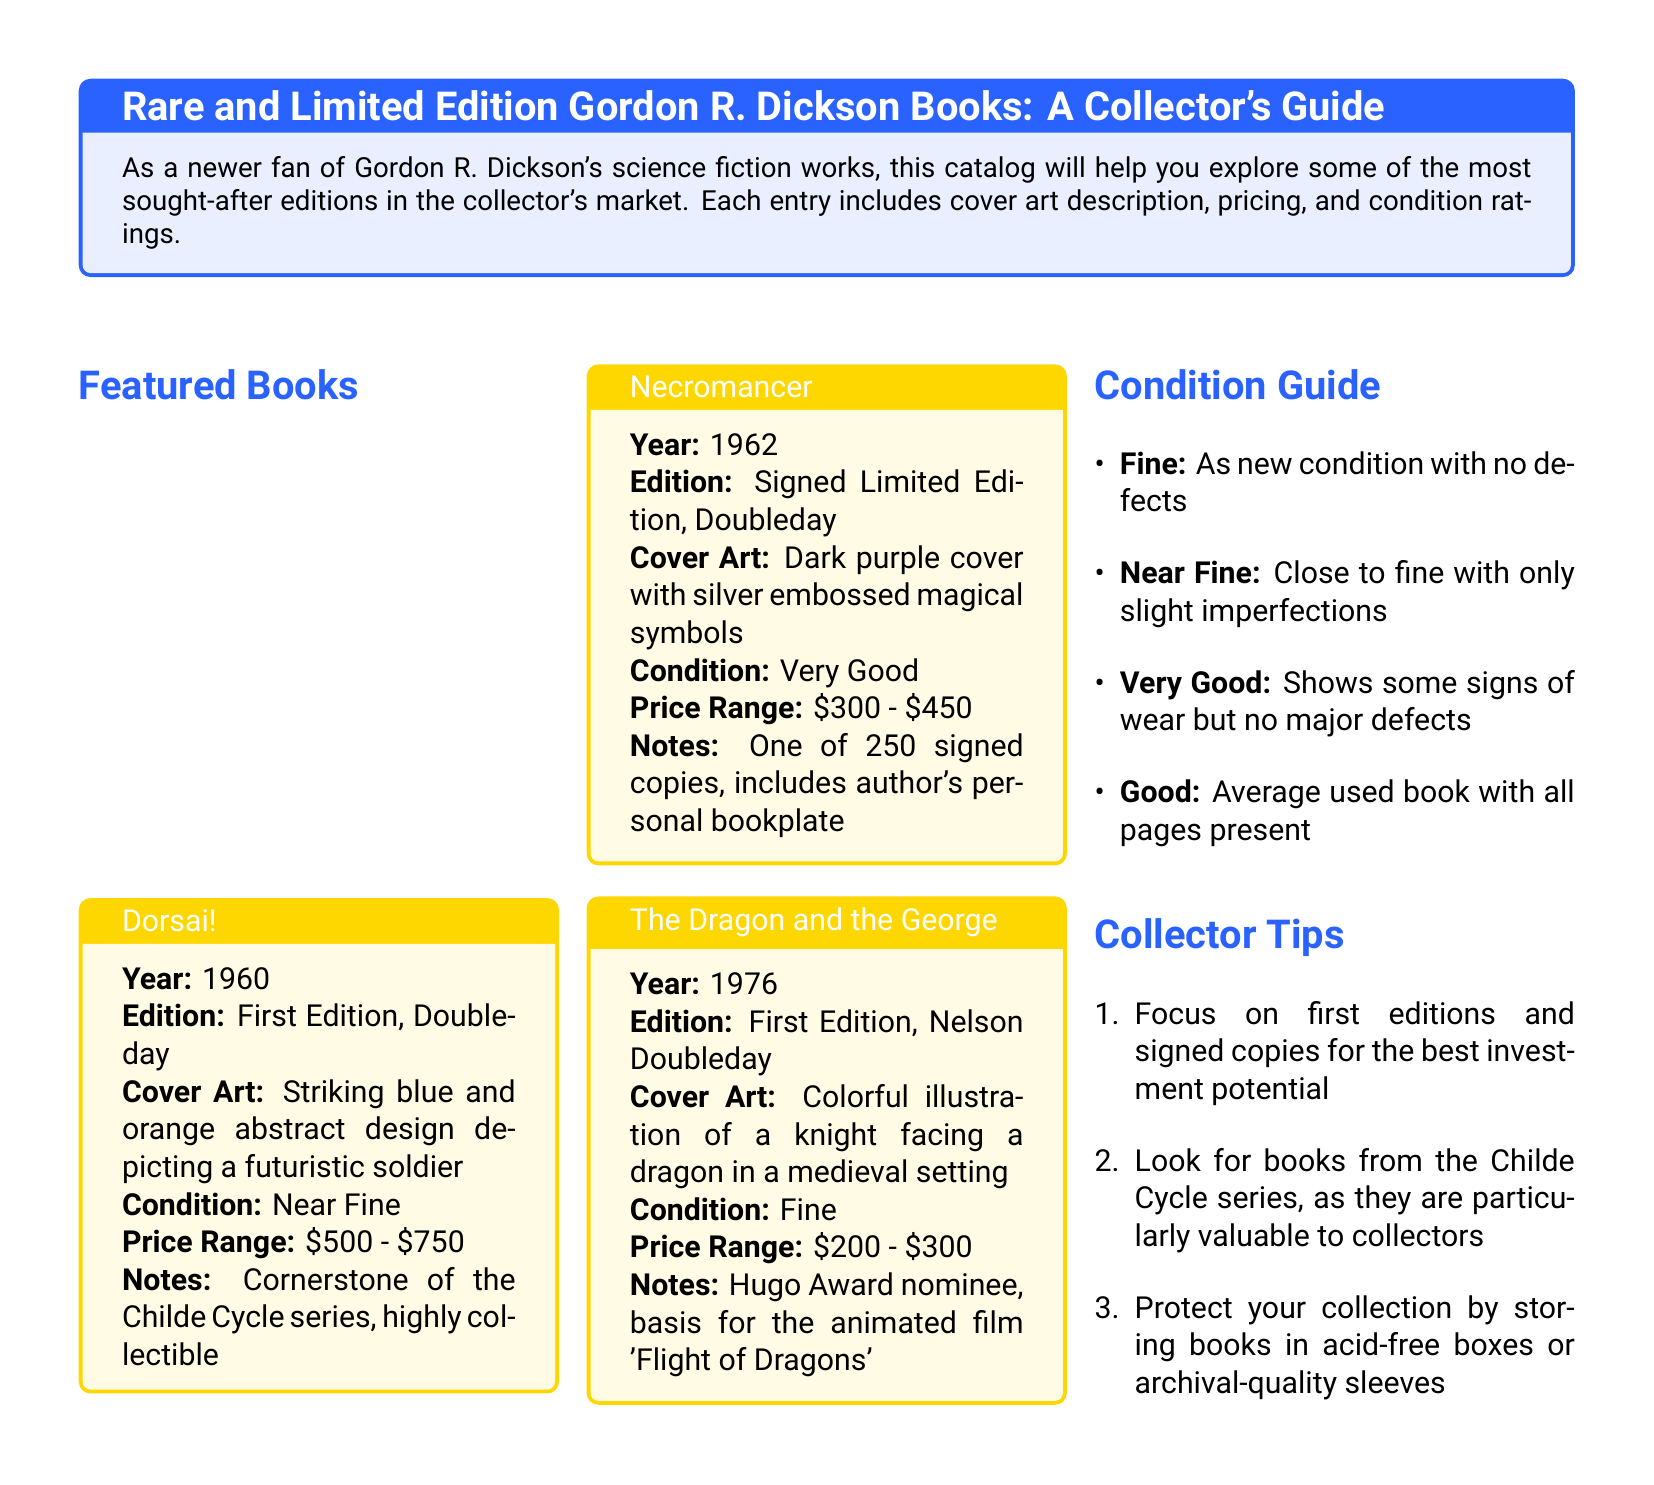What is the year of the first edition of Dorsai!? The document states that Dorsai! was published in 1960.
Answer: 1960 What is the price range for Necromancer? The price range for Necromancer as mentioned in the document is from $300 to $450.
Answer: $300 - $450 What condition is The Dragon and the George rated? The document indicates that The Dragon and the George is rated as Fine.
Answer: Fine How many signed copies of Necromancer exist? It states in the document that there are 250 signed copies of Necromancer.
Answer: 250 What is the cover art description of Dorsai!? The cover art of Dorsai! is described as a striking blue and orange abstract design depicting a futuristic soldier.
Answer: Striking blue and orange abstract design depicting a futuristic soldier Which series is highlighted for its collectible value in the tips? The Childe Cycle series is mentioned in the document as particularly valuable to collectors.
Answer: Childe Cycle What is one way to protect a collection mentioned in the tips? The document suggests storing books in acid-free boxes or archival-quality sleeves as a way to protect the collection.
Answer: Acid-free boxes or archival-quality sleeves What type of book is Necromancer? Necromancer is described as a Signed Limited Edition in the document.
Answer: Signed Limited Edition 